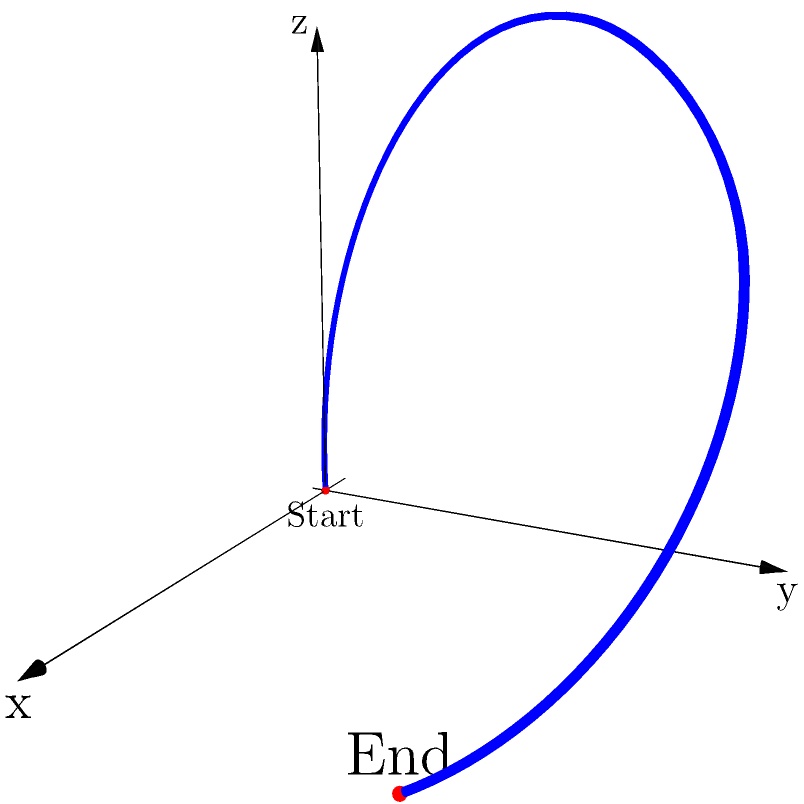A gymnast performs a somersault starting from a stationary position on the ground and landing 3 meters away. The highest point of the somersault is 3 meters above the ground and occurs at the midpoint of the horizontal distance traveled. If the x-axis represents the horizontal distance, the y-axis represents the lateral displacement, and the z-axis represents the height, which of the following equations best represents the trajectory of the gymnast's center of mass during the somersault?

A) $z = -\frac{4}{3}x^2 + 4x$
B) $z = -\frac{1}{3}x^2 + x$
C) $z = -\frac{4}{9}x^2 + 2x$
D) $z = -\frac{1}{9}x^2 + x$ To solve this problem, let's follow these steps:

1) We know that:
   - The somersault starts at (0,0,0) and ends at (3,0,0)
   - The highest point is 3 meters high and occurs at x = 1.5 meters

2) The general equation for a parabola with a vertical axis of symmetry is:
   $z = ax^2 + bx + c$

3) We can use the three known points to set up a system of equations:
   (0,0,0): $0 = a(0)^2 + b(0) + c$, so $c = 0$
   (3,0,0): $0 = a(3)^2 + b(3)$
   (1.5,3): $3 = a(1.5)^2 + b(1.5)$

4) From the first equation, we know c = 0. Let's solve the other two:
   $0 = 9a + 3b$  (Equation 1)
   $3 = 2.25a + 1.5b$  (Equation 2)

5) Multiply Equation 1 by 0.5:
   $0 = 4.5a + 1.5b$  (Equation 3)

6) Subtract Equation 3 from Equation 2:
   $3 = -2.25a$
   $a = -\frac{4}{3}$

7) Substitute this back into Equation 1:
   $0 = 9(-\frac{4}{3}) + 3b$
   $0 = -12 + 3b$
   $b = 4$

8) Therefore, the equation of the trajectory is:
   $z = -\frac{4}{3}x^2 + 4x$

This matches option A in the question.
Answer: A) $z = -\frac{4}{3}x^2 + 4x$ 